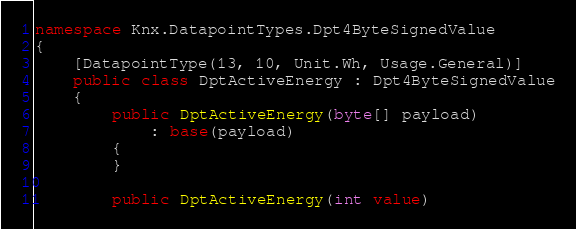Convert code to text. <code><loc_0><loc_0><loc_500><loc_500><_C#_>namespace Knx.DatapointTypes.Dpt4ByteSignedValue
{
    [DatapointType(13, 10, Unit.Wh, Usage.General)]
    public class DptActiveEnergy : Dpt4ByteSignedValue
    {
        public DptActiveEnergy(byte[] payload)
            : base(payload)
        {
        }

        public DptActiveEnergy(int value)</code> 